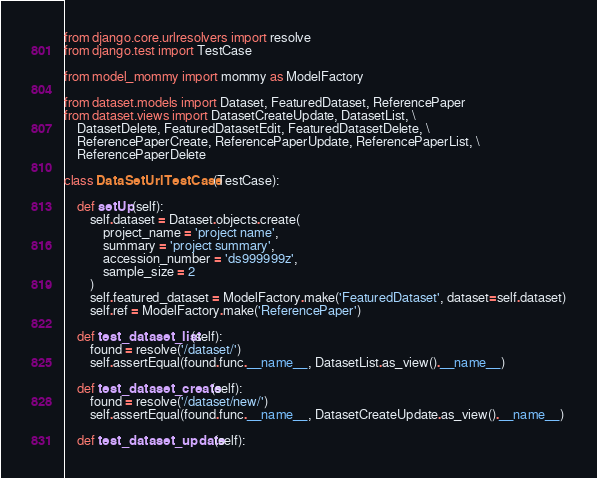Convert code to text. <code><loc_0><loc_0><loc_500><loc_500><_Python_>from django.core.urlresolvers import resolve
from django.test import TestCase

from model_mommy import mommy as ModelFactory

from dataset.models import Dataset, FeaturedDataset, ReferencePaper
from dataset.views import DatasetCreateUpdate, DatasetList, \
    DatasetDelete, FeaturedDatasetEdit, FeaturedDatasetDelete, \
    ReferencePaperCreate, ReferencePaperUpdate, ReferencePaperList, \
    ReferencePaperDelete

class DataSetUrlTestCase(TestCase):

    def setUp(self):
        self.dataset = Dataset.objects.create(
            project_name = 'project name',
            summary = 'project summary',
            accession_number = 'ds999999z',
            sample_size = 2
        )
        self.featured_dataset = ModelFactory.make('FeaturedDataset', dataset=self.dataset)
        self.ref = ModelFactory.make('ReferencePaper')
    
    def test_dataset_list(self):
        found = resolve('/dataset/')
        self.assertEqual(found.func.__name__, DatasetList.as_view().__name__)

    def test_dataset_create(self):
        found = resolve('/dataset/new/')
        self.assertEqual(found.func.__name__, DatasetCreateUpdate.as_view().__name__)

    def test_dataset_update(self):</code> 